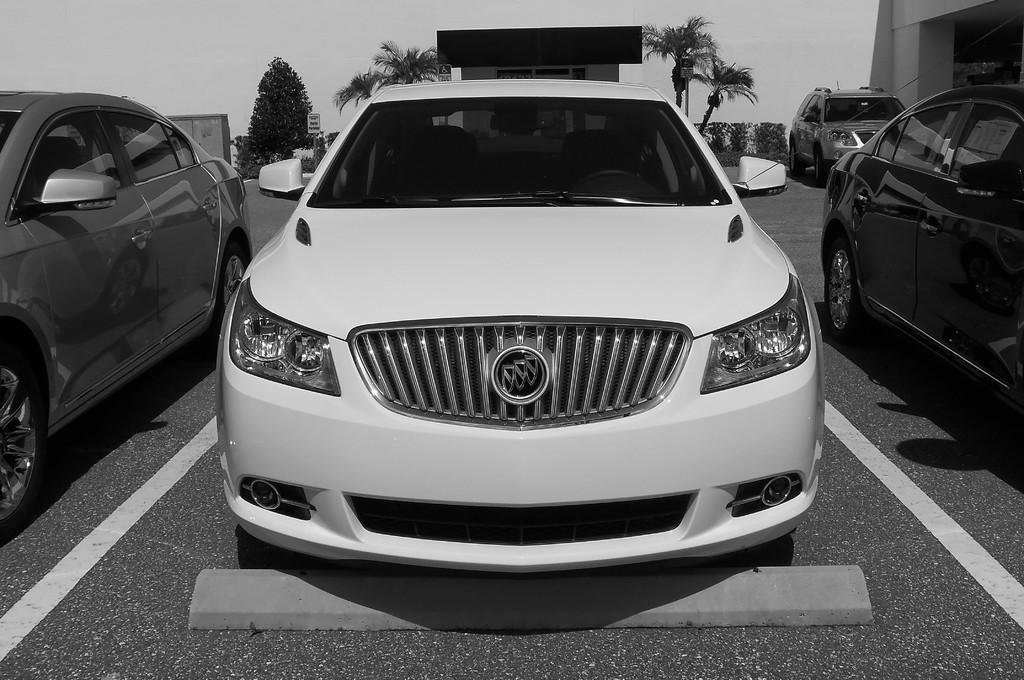What can be seen on the road in the image? There are cars parked on the road in the image. What is visible in the background of the image? There is a building, trees, and the sky visible in the background of the image. How many receipts can be seen on the ground near the cars in the image? There are no receipts visible on the ground near the cars in the image. 